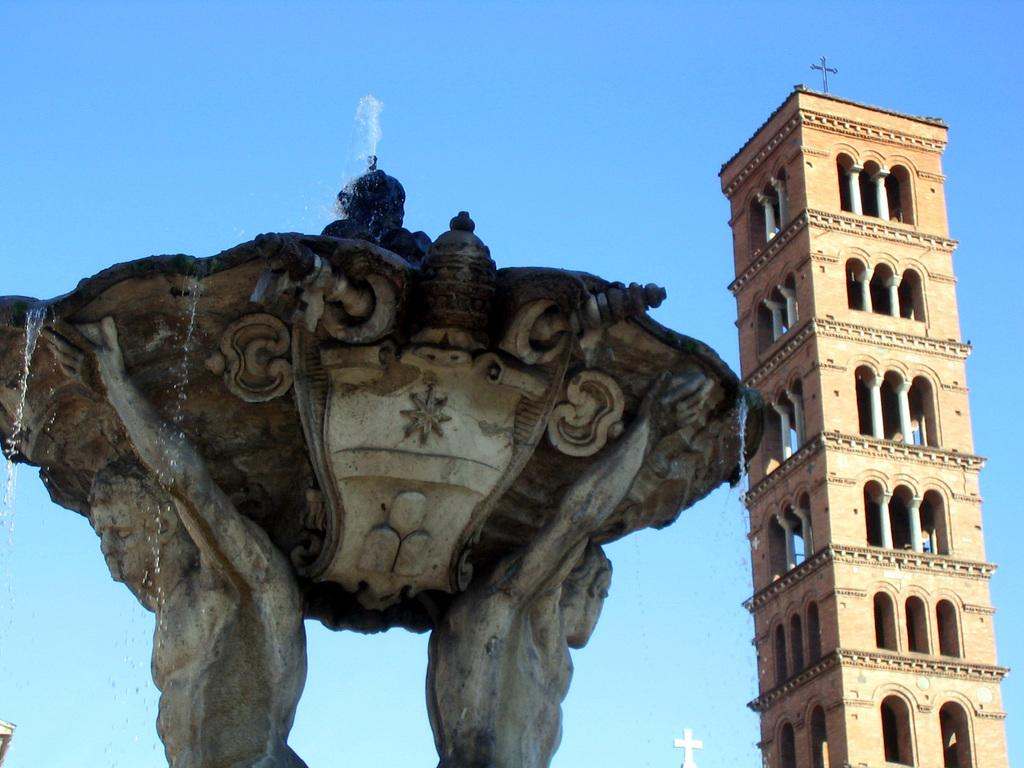What is the main subject in the image? There is a statue in the image. What else can be seen in the image besides the statue? There are buildings and a fountain in the image. What is visible in the background of the image? The sky is visible in the image. Can you describe the time of day when the image was likely taken? The image was likely taken during the day, as there is no indication of darkness or artificial lighting. What type of silverware is being used to cut the quince in the image? There is no silverware or quince present in the image; it features a statue, buildings, a fountain, and the sky. What sign is displayed on the statue in the image? There is no sign displayed on the statue in the image; it is a standalone statue. 